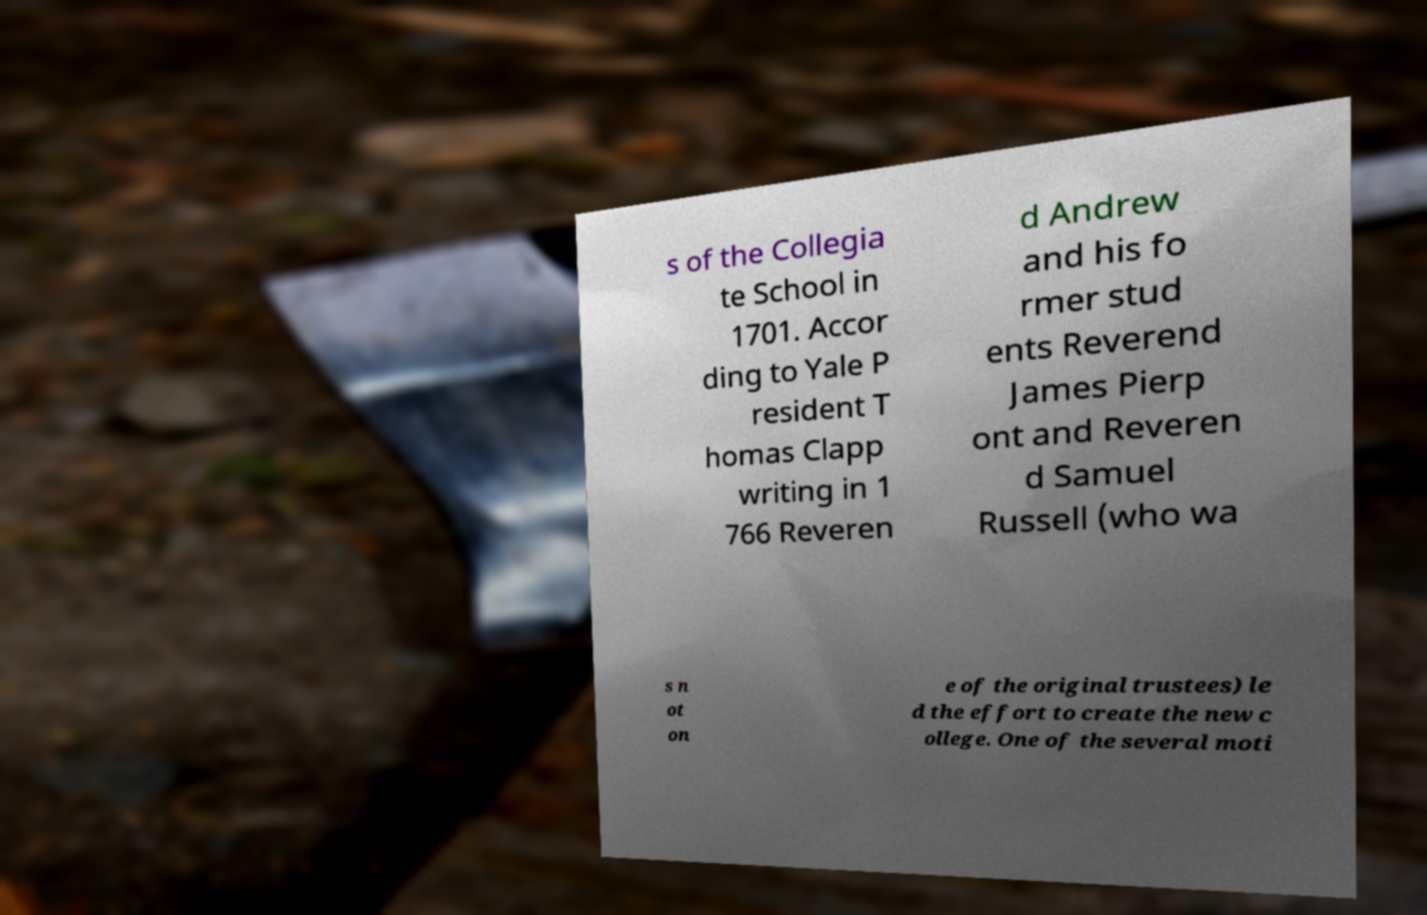I need the written content from this picture converted into text. Can you do that? s of the Collegia te School in 1701. Accor ding to Yale P resident T homas Clapp writing in 1 766 Reveren d Andrew and his fo rmer stud ents Reverend James Pierp ont and Reveren d Samuel Russell (who wa s n ot on e of the original trustees) le d the effort to create the new c ollege. One of the several moti 